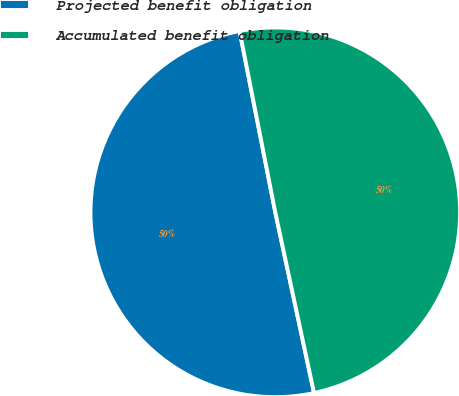Convert chart to OTSL. <chart><loc_0><loc_0><loc_500><loc_500><pie_chart><fcel>Projected benefit obligation<fcel>Accumulated benefit obligation<nl><fcel>50.27%<fcel>49.73%<nl></chart> 